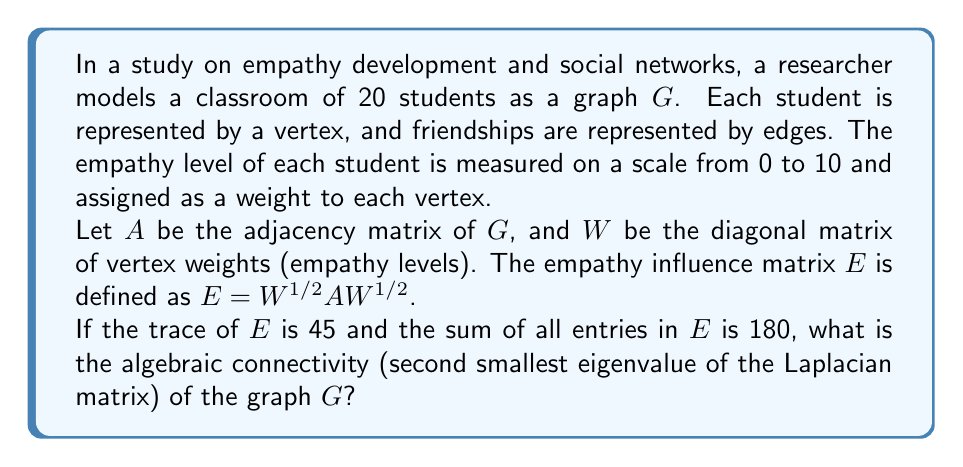Give your solution to this math problem. Let's approach this step-by-step:

1) First, we need to understand what the given information tells us:
   - The trace of $E$ is 45
   - The sum of all entries in $E$ is 180
   - $E = W^{1/2}AW^{1/2}$

2) The trace of $E$ is equal to the sum of its diagonal entries. In this case, $tr(E) = 45$.

3) The sum of all entries in $E$ is 180. Let's call this sum $S(E) = 180$.

4) Now, let's consider the Laplacian matrix $L$ of the graph $G$. It's defined as $L = D - A$, where $D$ is the degree matrix and $A$ is the adjacency matrix.

5) The algebraic connectivity is the second smallest eigenvalue of $L$. Let's call it $\lambda_2(L)$.

6) A key relationship in algebraic graph theory is:

   $$\lambda_2(L) = \min_{x \perp \mathbf{1}, x \neq 0} \frac{x^T L x}{x^T x}$$

7) For our empathy-weighted graph, we can modify this to:

   $$\lambda_2(L) = \min_{x \perp W^{1/2}\mathbf{1}, x \neq 0} \frac{x^T W^{1/2}LW^{1/2} x}{x^T x}$$

8) The matrix $W^{1/2}LW^{1/2}$ can be expressed as:

   $$W^{1/2}LW^{1/2} = W^{1/2}DW^{1/2} - W^{1/2}AW^{1/2} = W^{1/2}DW^{1/2} - E$$

9) The trace of $W^{1/2}DW^{1/2}$ is equal to the sum of all edge weights in the graph. Let's call this $2m$, where $m$ is the number of edges.

10) Therefore:

    $$tr(W^{1/2}LW^{1/2}) = 2m - tr(E) = 2m - 45$$

11) The sum of all entries in $W^{1/2}LW^{1/2}$ is:

    $$S(W^{1/2}LW^{1/2}) = 0 - S(E) = -180$$

12) From the properties of eigenvalues, we know that:

    $$\sum_{i=1}^n \lambda_i(W^{1/2}LW^{1/2}) = tr(W^{1/2}LW^{1/2}) = 2m - 45$$

13) We also know that the smallest eigenvalue of $L$ (and thus of $W^{1/2}LW^{1/2}$) is always 0.

14) Therefore:

    $$\lambda_2(W^{1/2}LW^{1/2}) = \frac{2m - 45 - S(W^{1/2}LW^{1/2})}{n-1} = \frac{2m - 45 + 180}{19} = \frac{2m + 135}{19}$$

15) The number of edges $m$ can be calculated from the sum of entries in $E$:

    $$S(E) = 2m \Rightarrow m = 90$$

16) Substituting this back:

    $$\lambda_2(W^{1/2}LW^{1/2}) = \frac{2(90) + 135}{19} = \frac{315}{19} = \frac{45}{3} = 15$$

Therefore, the algebraic connectivity of the graph $G$ is 15.
Answer: 15 